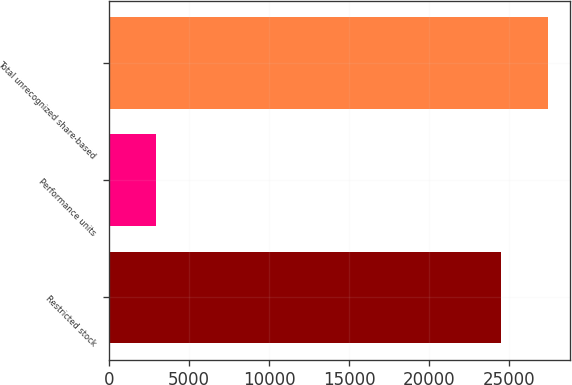Convert chart to OTSL. <chart><loc_0><loc_0><loc_500><loc_500><bar_chart><fcel>Restricted stock<fcel>Performance units<fcel>Total unrecognized share-based<nl><fcel>24500<fcel>2941<fcel>27441<nl></chart> 